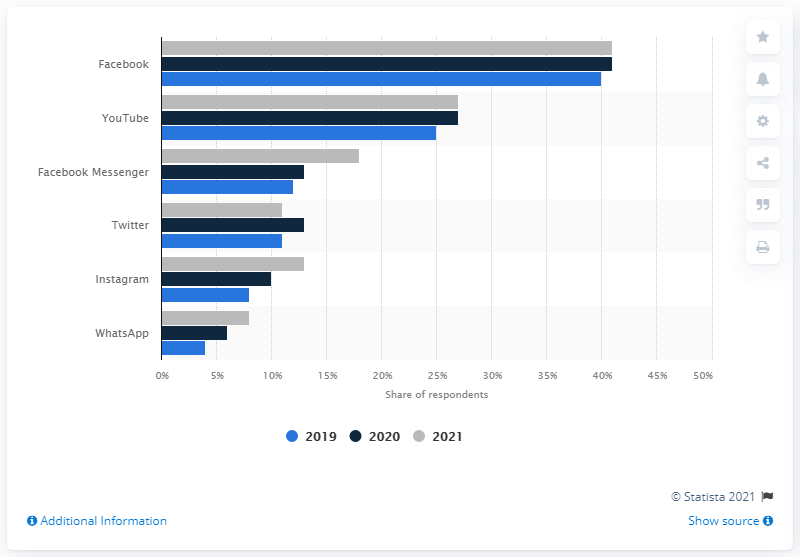Highlight a few significant elements in this photo. Twitter experienced a decline in popularity in Canada in 2021, according to a social network. In 2021, Facebook was the most popular news source in Canada. 